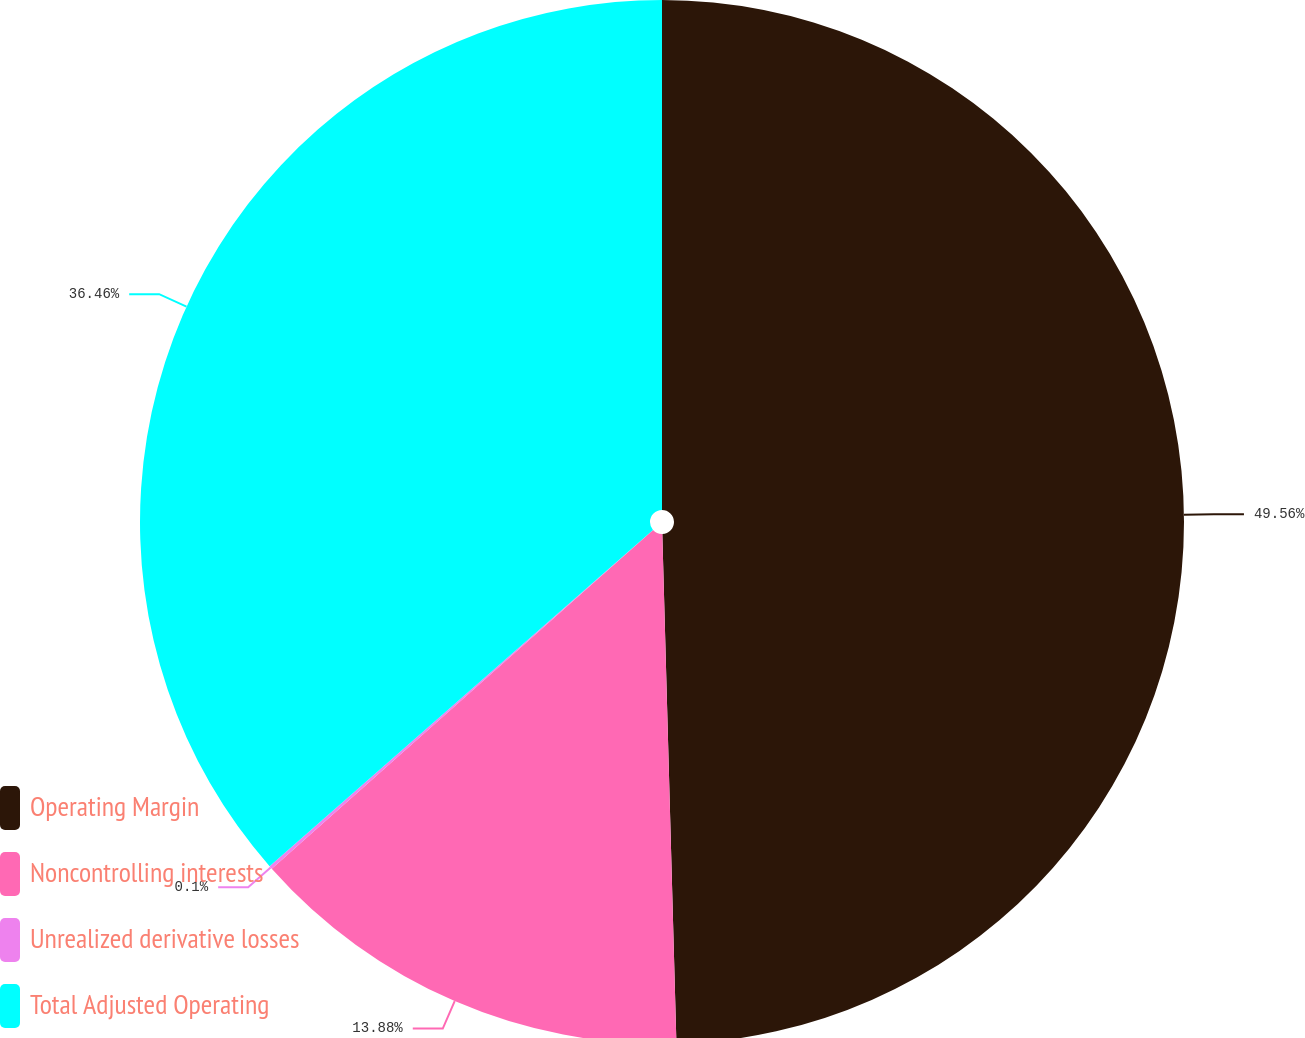Convert chart. <chart><loc_0><loc_0><loc_500><loc_500><pie_chart><fcel>Operating Margin<fcel>Noncontrolling interests<fcel>Unrealized derivative losses<fcel>Total Adjusted Operating<nl><fcel>49.56%<fcel>13.88%<fcel>0.1%<fcel>36.46%<nl></chart> 